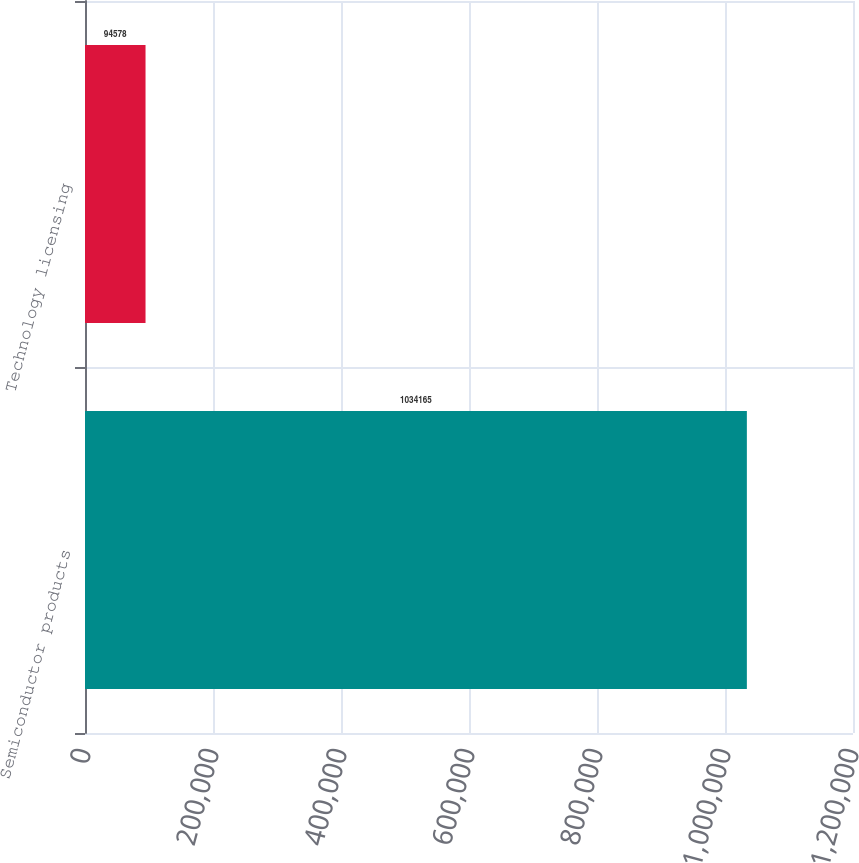<chart> <loc_0><loc_0><loc_500><loc_500><bar_chart><fcel>Semiconductor products<fcel>Technology licensing<nl><fcel>1.03416e+06<fcel>94578<nl></chart> 